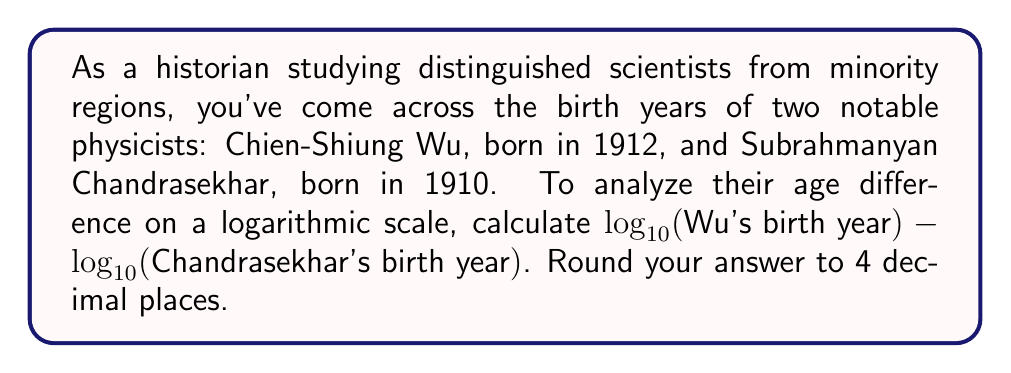Help me with this question. To solve this problem, we need to follow these steps:

1. Identify the birth years:
   Chien-Shiung Wu: 1912
   Subrahmanyan Chandrasekhar: 1910

2. Calculate $\log_{10}$ of each birth year:

   For Wu: $\log_{10}(1912)$
   For Chandrasekhar: $\log_{10}(1910)$

3. Subtract the logarithms:
   $\log_{10}(1912) - \log_{10}(1910)$

4. Use the logarithm property: $\log_a(x) - \log_a(y) = \log_a(\frac{x}{y})$

   So, our calculation becomes: $\log_{10}(\frac{1912}{1910})$

5. Perform the division inside the logarithm:
   $\frac{1912}{1910} = 1.001047120418848$

6. Calculate the logarithm:
   $\log_{10}(1.001047120418848) = 0.000454545454545$

7. Round to 4 decimal places:
   0.0005

This logarithmic difference represents the relative age difference between the two scientists on a logarithmic scale.
Answer: 0.0005 